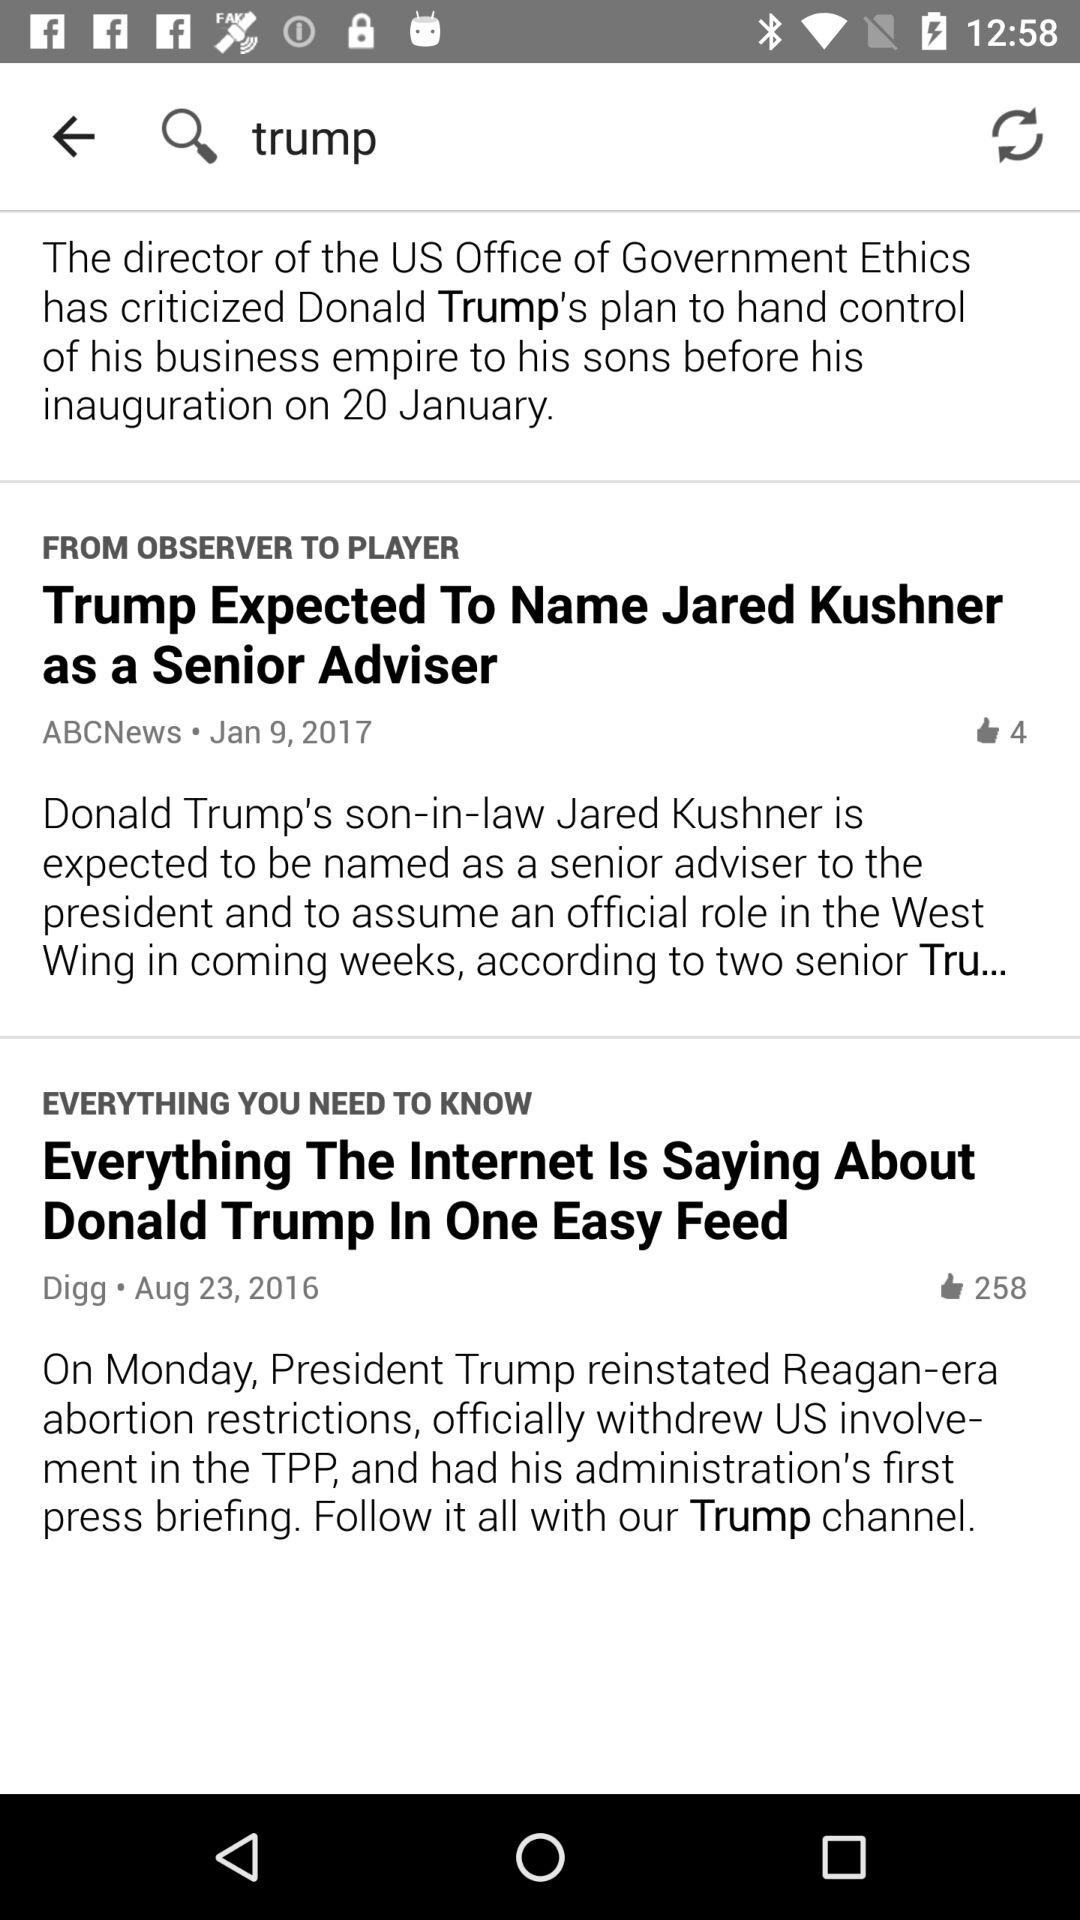What is the Digg's headline? The Digg's headline is "Everything The Internet Is Saying About Donald Trump In One Easy Feed". 